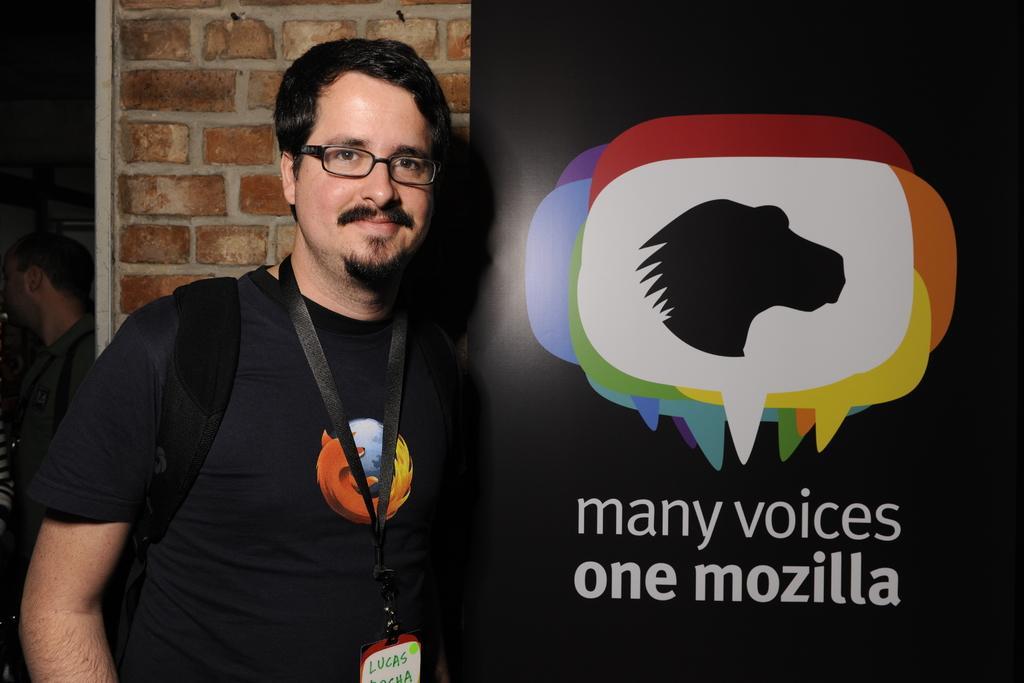Could you give a brief overview of what you see in this image? In this picture we can see one person holding a bag and standing beside the board, back side we can see one person. 